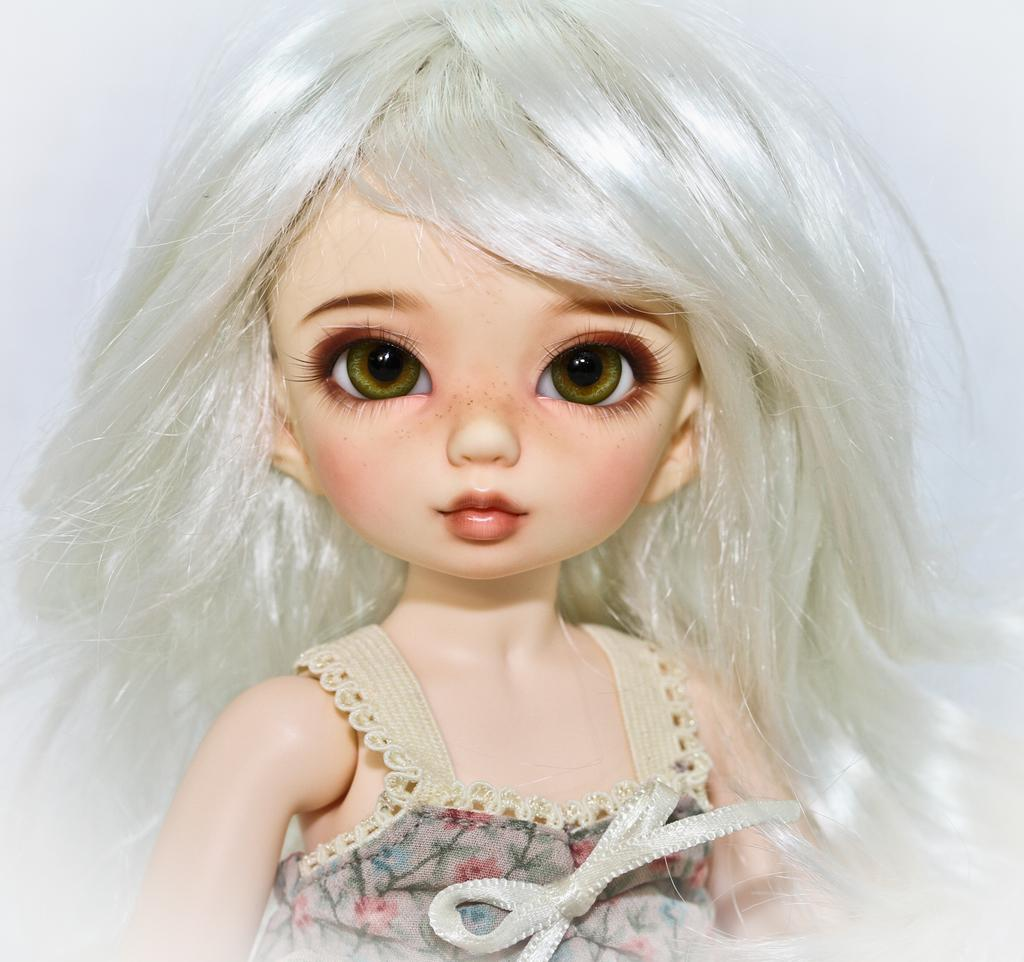What is the main subject of the image? There is a doll in the image. What color is the background of the image? The background of the image is white. What type of amusement can be seen in the image? There is no amusement present in the image; it features a doll against a white background. What kind of pets are visible in the image? There are no pets visible in the image; it features a doll against a white background. 